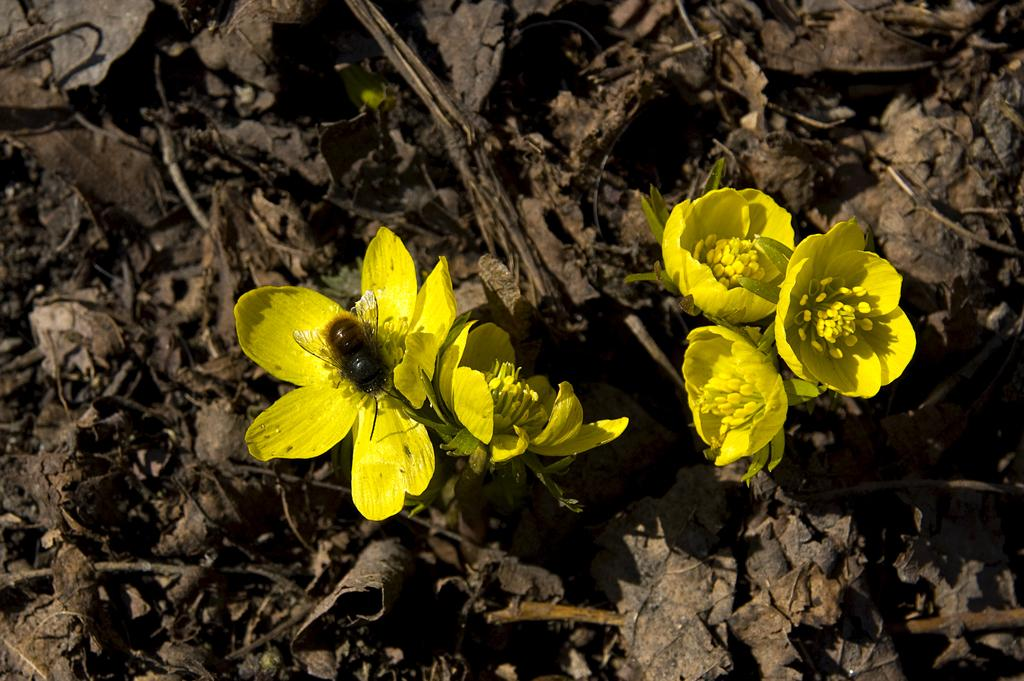What type of flowers can be seen in the image? There are yellow color flowers in the image. Is there any other living organism present in the image? Yes, there is an insect on a flower in the image. What can be seen in the background of the image? Dried leaves are present in the background of the image. What type of club does the giant hold in the image? There are no giants or clubs present in the image. 